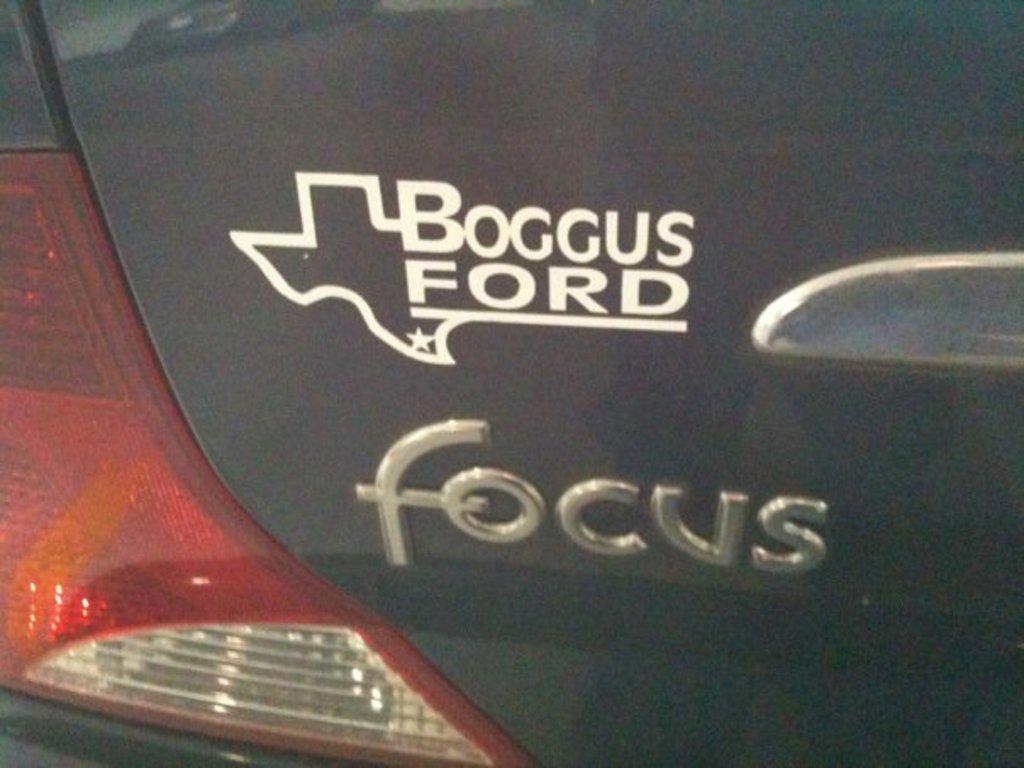Please provide a concise description of this image. In this picture there is a black car. In the center i can see the sticker and company's name. On the left there is a light. 